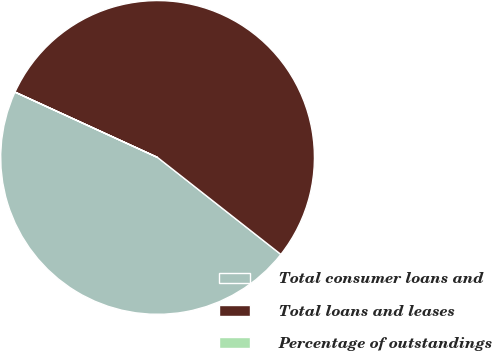Convert chart. <chart><loc_0><loc_0><loc_500><loc_500><pie_chart><fcel>Total consumer loans and<fcel>Total loans and leases<fcel>Percentage of outstandings<nl><fcel>46.23%<fcel>53.76%<fcel>0.01%<nl></chart> 